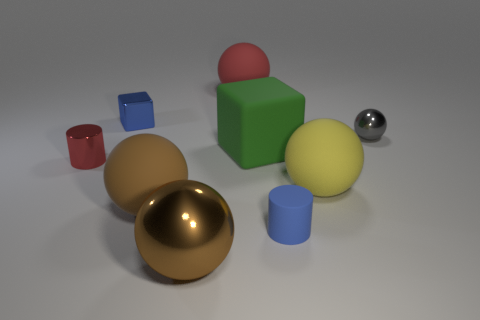How many big balls are both in front of the green matte object and on the left side of the small blue rubber cylinder?
Provide a short and direct response. 2. There is a cylinder in front of the tiny metallic cylinder; what is its size?
Offer a very short reply. Small. What number of other objects are there of the same color as the big metal thing?
Give a very brief answer. 1. What material is the small cylinder behind the large yellow sphere that is behind the brown matte sphere made of?
Offer a terse response. Metal. Do the rubber ball that is behind the large green rubber object and the large metal object have the same color?
Provide a short and direct response. No. How many large red rubber objects are the same shape as the yellow object?
Provide a short and direct response. 1. There is another sphere that is made of the same material as the gray sphere; what size is it?
Provide a short and direct response. Large. Is there a gray metal ball that is in front of the cylinder in front of the large rubber ball in front of the large yellow rubber sphere?
Give a very brief answer. No. There is a shiny ball in front of the yellow rubber sphere; does it have the same size as the tiny metallic cylinder?
Your answer should be compact. No. How many other matte objects are the same size as the yellow thing?
Your response must be concise. 3. 